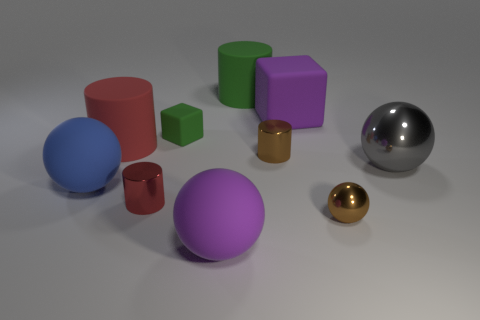Subtract all cylinders. How many objects are left? 6 Subtract 1 brown spheres. How many objects are left? 9 Subtract all blue cylinders. Subtract all gray balls. How many objects are left? 9 Add 3 red matte objects. How many red matte objects are left? 4 Add 1 big brown cylinders. How many big brown cylinders exist? 1 